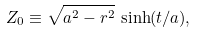Convert formula to latex. <formula><loc_0><loc_0><loc_500><loc_500>Z _ { 0 } \equiv \sqrt { a ^ { 2 } - r ^ { 2 } } \, \sinh ( t / a ) ,</formula> 